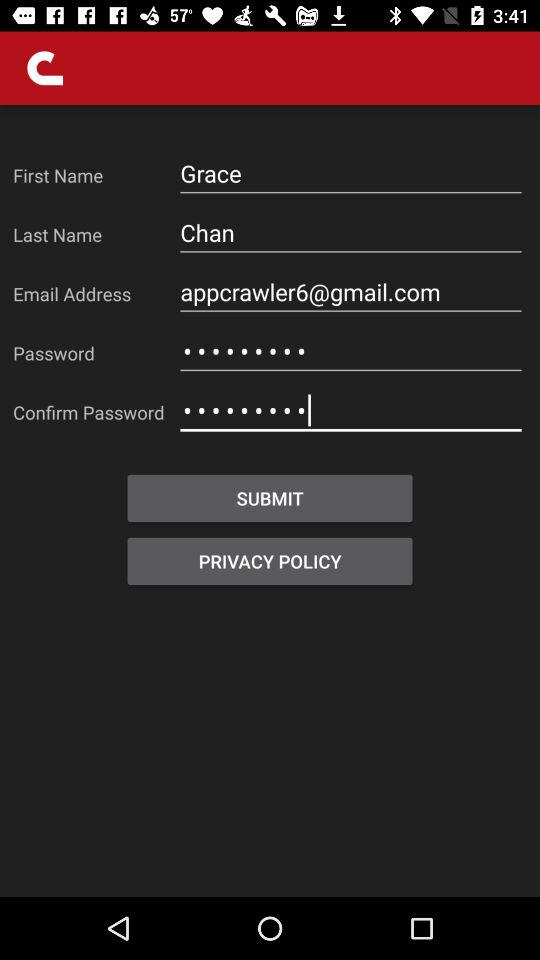What is the email address? The email address is appcrawler6@gmail.com. 